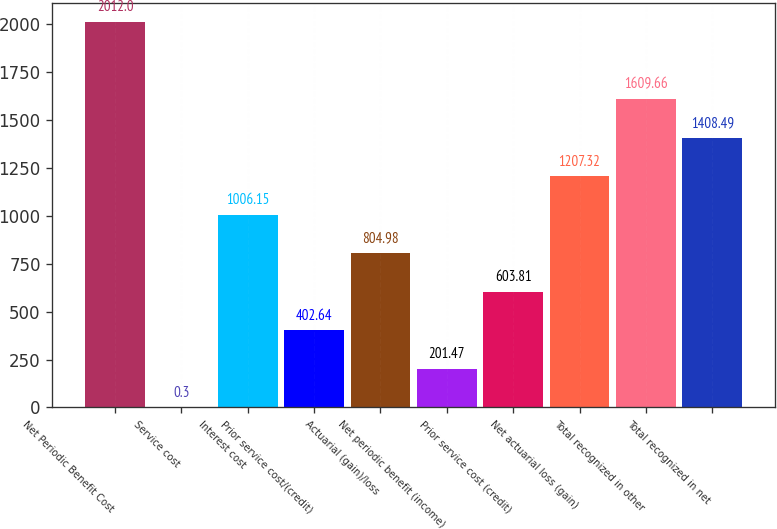Convert chart to OTSL. <chart><loc_0><loc_0><loc_500><loc_500><bar_chart><fcel>Net Periodic Benefit Cost<fcel>Service cost<fcel>Interest cost<fcel>Prior service cost/(credit)<fcel>Actuarial (gain)/loss<fcel>Net periodic benefit (income)<fcel>Prior service cost (credit)<fcel>Net actuarial loss (gain)<fcel>Total recognized in other<fcel>Total recognized in net<nl><fcel>2012<fcel>0.3<fcel>1006.15<fcel>402.64<fcel>804.98<fcel>201.47<fcel>603.81<fcel>1207.32<fcel>1609.66<fcel>1408.49<nl></chart> 